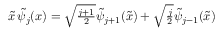<formula> <loc_0><loc_0><loc_500><loc_500>\begin{array} { r } { \tilde { x } \, \tilde { \psi } _ { j } ( x ) = \sqrt { \frac { j + 1 } { 2 } } \tilde { \psi } _ { j + 1 } ( \tilde { x } ) + \sqrt { \frac { j } { 2 } } \tilde { \psi } _ { j - 1 } ( \tilde { x } ) } \end{array}</formula> 